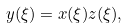Convert formula to latex. <formula><loc_0><loc_0><loc_500><loc_500>y ( \xi ) = x ( \xi ) z ( \xi ) ,</formula> 